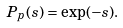<formula> <loc_0><loc_0><loc_500><loc_500>P _ { p } ( s ) = \exp ( - s ) .</formula> 